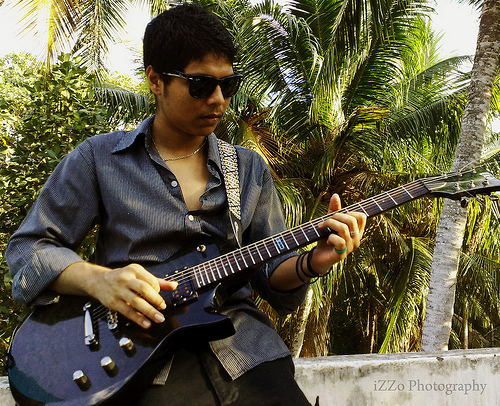<image>
Can you confirm if the guitar is in front of the tree? Yes. The guitar is positioned in front of the tree, appearing closer to the camera viewpoint. 